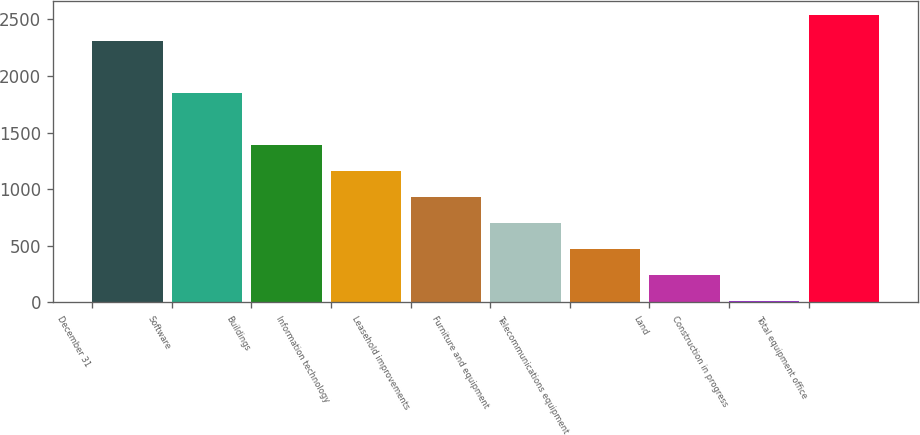Convert chart to OTSL. <chart><loc_0><loc_0><loc_500><loc_500><bar_chart><fcel>December 31<fcel>Software<fcel>Buildings<fcel>Information technology<fcel>Leasehold improvements<fcel>Furniture and equipment<fcel>Telecommunications equipment<fcel>Land<fcel>Construction in progress<fcel>Total equipment office<nl><fcel>2308<fcel>1849.4<fcel>1390.8<fcel>1161.5<fcel>932.2<fcel>702.9<fcel>473.6<fcel>244.3<fcel>15<fcel>2537.3<nl></chart> 